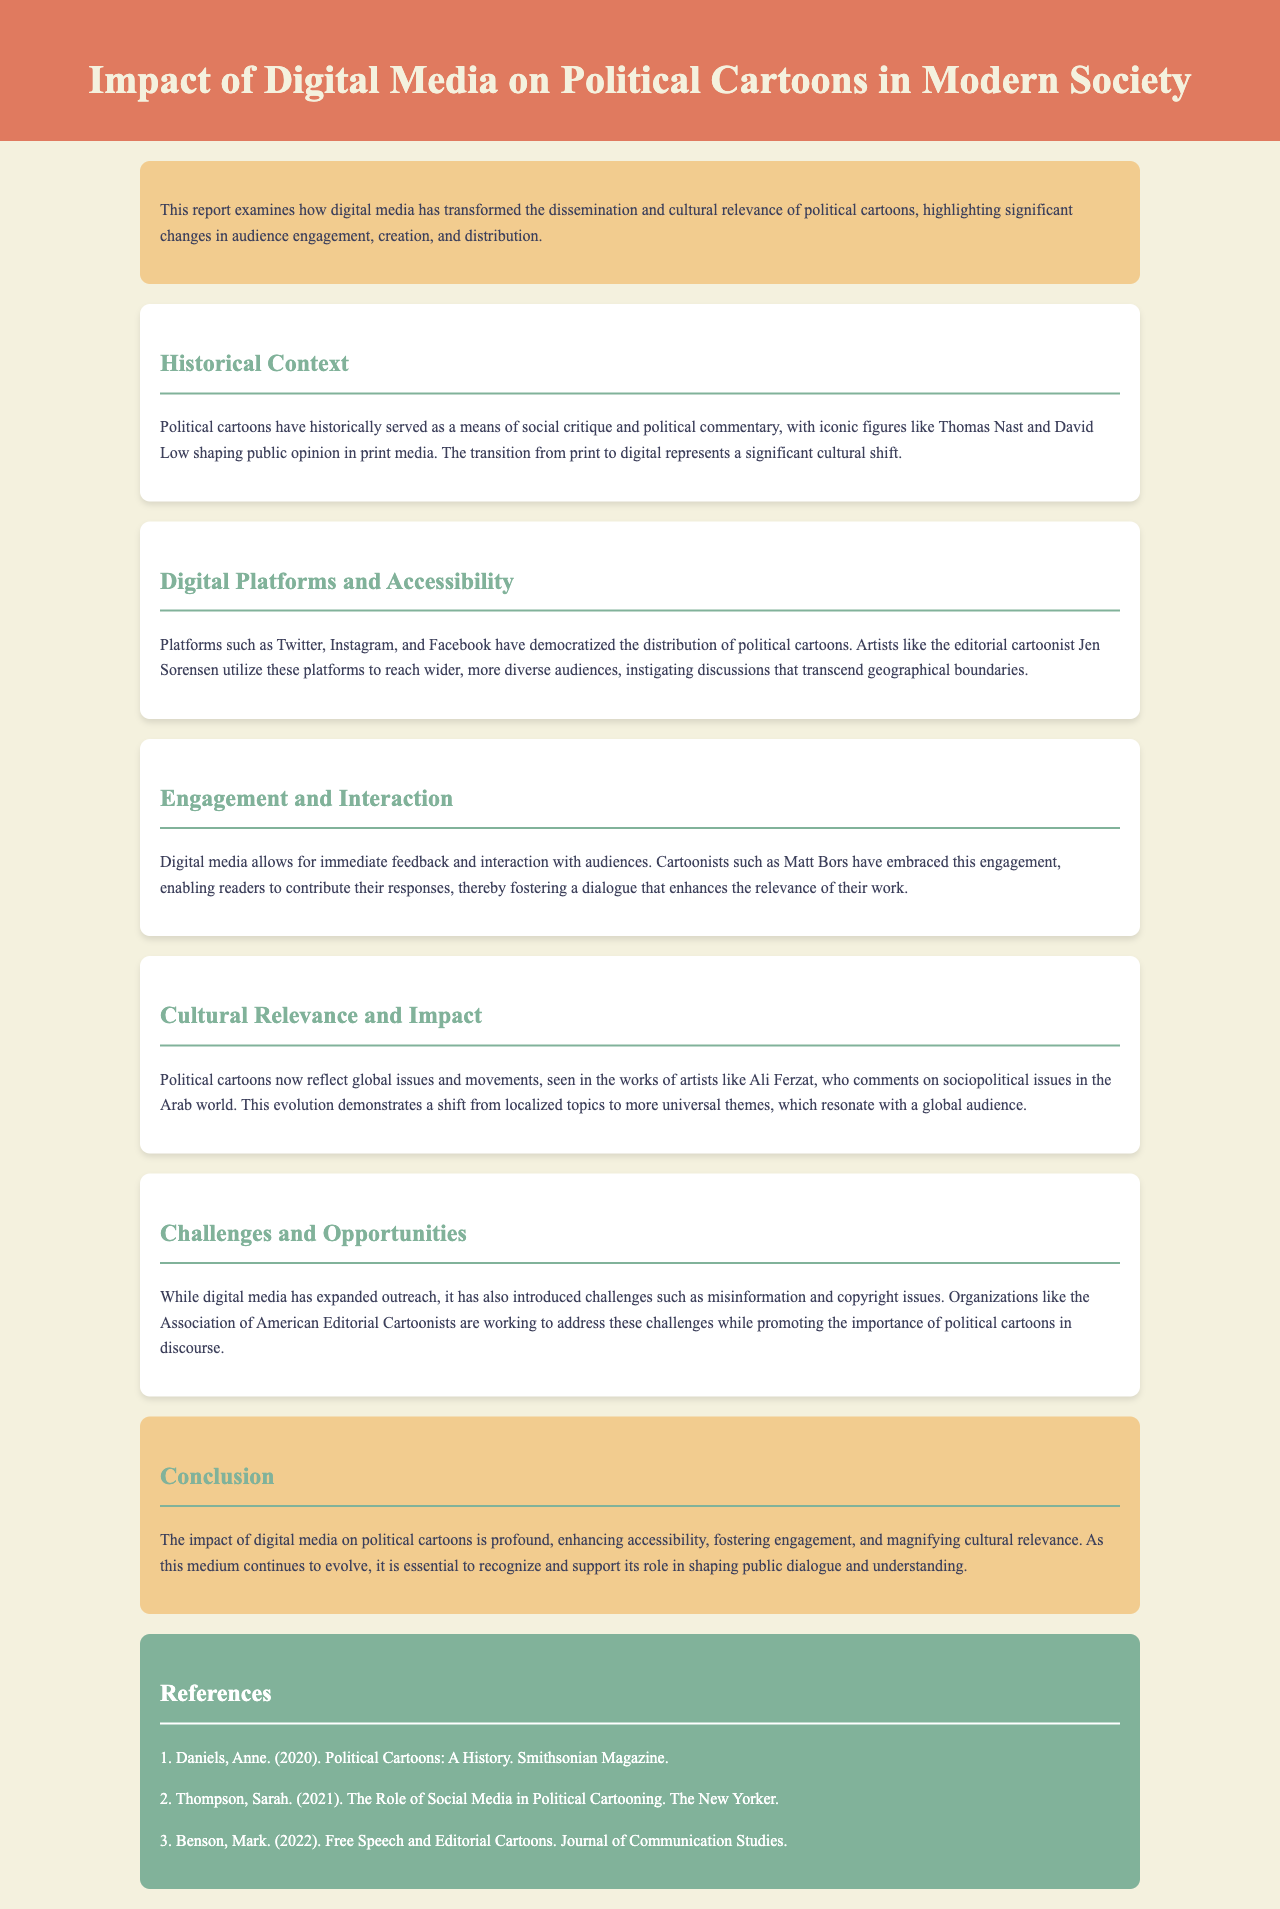What does this report examine? The report examines how digital media has transformed the dissemination and cultural relevance of political cartoons.
Answer: Transformation of dissemination and cultural relevance Who are two historical figures mentioned in the document? The document mentions Thomas Nast and David Low as iconic figures in political cartoons.
Answer: Thomas Nast and David Low Which social media platforms are highlighted for democratizing the distribution of political cartoons? The highlighted social media platforms include Twitter, Instagram, and Facebook.
Answer: Twitter, Instagram, and Facebook Who is identified as an editorial cartoonist utilizing digital platforms? Jen Sorensen is mentioned as an editorial cartoonist utilizing digital platforms to reach wider audiences.
Answer: Jen Sorensen What challenge related to digital media is mentioned in the document? The document mentions misinformation as a challenge introduced by digital media.
Answer: Misinformation What is the role of the Association of American Editorial Cartoonists according to the report? The Association of American Editorial Cartoonists is working to address challenges while promoting the importance of political cartoons.
Answer: Address challenges and promote importance What significant cultural shift does the report refer to? The transition from print to digital media is referred to as a significant cultural shift.
Answer: Transition from print to digital Who is an artist that comments on sociopolitical issues in the Arab world? Ali Ferzat is identified as an artist who comments on sociopolitical issues in the Arab world.
Answer: Ali Ferzat What is the overarching impact of digital media on political cartoons as concluded in the report? The overarching impact is enhancing accessibility, fostering engagement, and magnifying cultural relevance.
Answer: Enhancing accessibility, fostering engagement, magnifying cultural relevance 